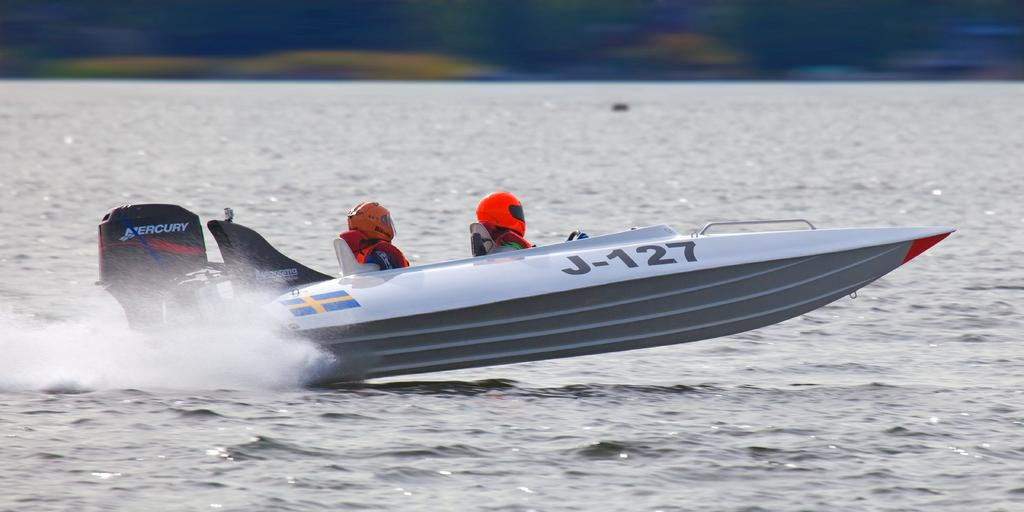<image>
Render a clear and concise summary of the photo. A speed boat with the number J-127 on its side carries two passengers. 